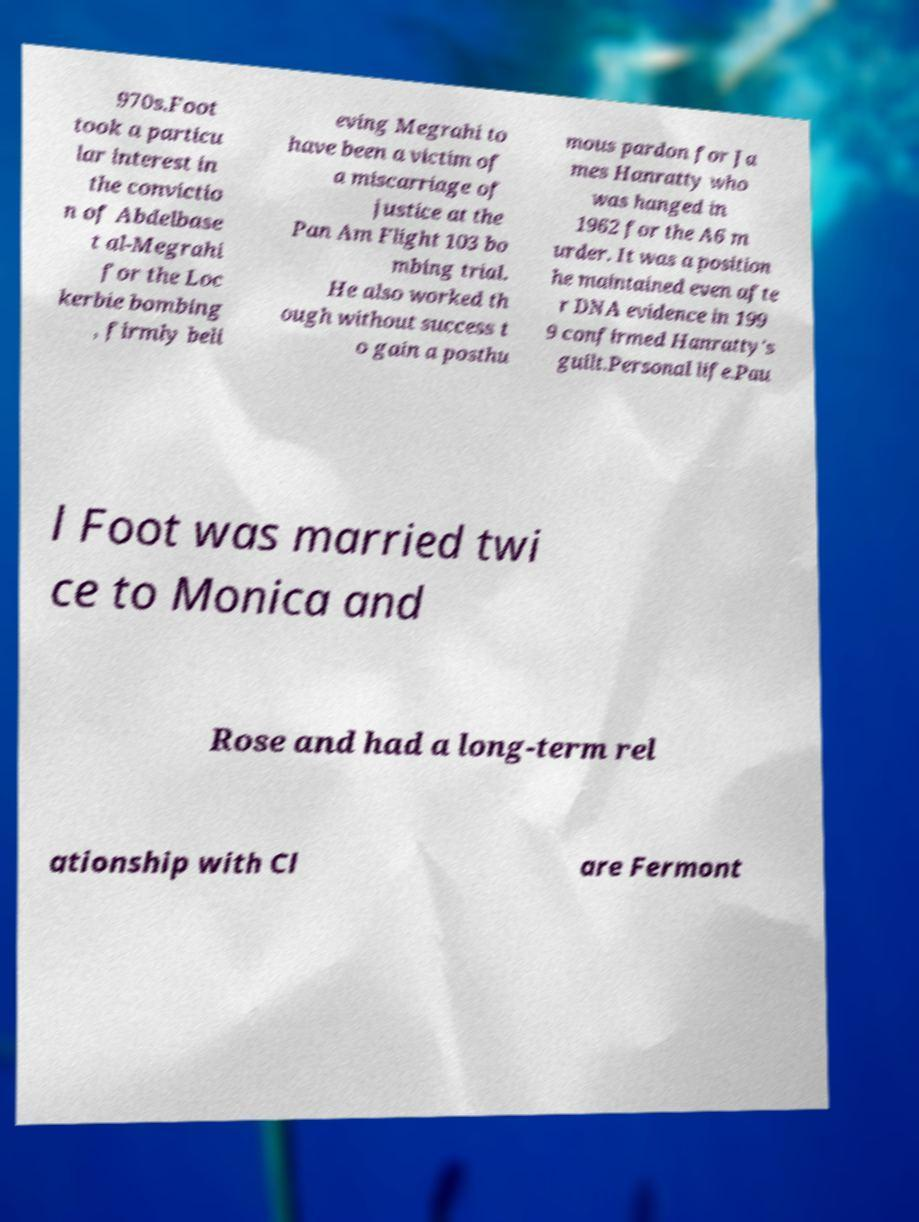Can you accurately transcribe the text from the provided image for me? 970s.Foot took a particu lar interest in the convictio n of Abdelbase t al-Megrahi for the Loc kerbie bombing , firmly beli eving Megrahi to have been a victim of a miscarriage of justice at the Pan Am Flight 103 bo mbing trial. He also worked th ough without success t o gain a posthu mous pardon for Ja mes Hanratty who was hanged in 1962 for the A6 m urder. It was a position he maintained even afte r DNA evidence in 199 9 confirmed Hanratty's guilt.Personal life.Pau l Foot was married twi ce to Monica and Rose and had a long-term rel ationship with Cl are Fermont 